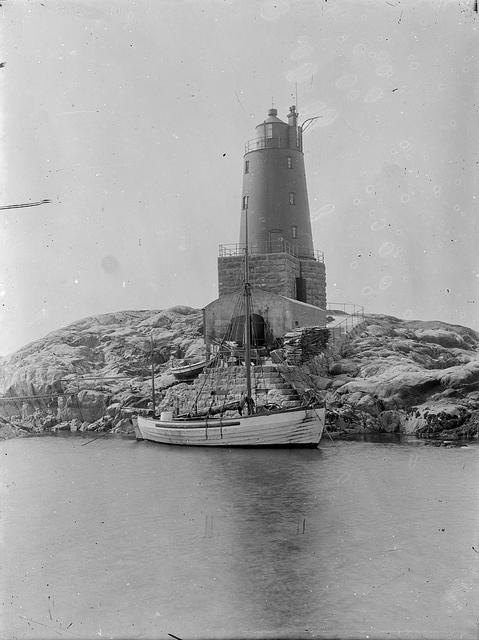What is the building?
Short answer required. Lighthouse. Is this a black and white photo?
Keep it brief. Yes. Is this lighthouse beautiful?
Give a very brief answer. Yes. What is in the water?
Concise answer only. Boat. 